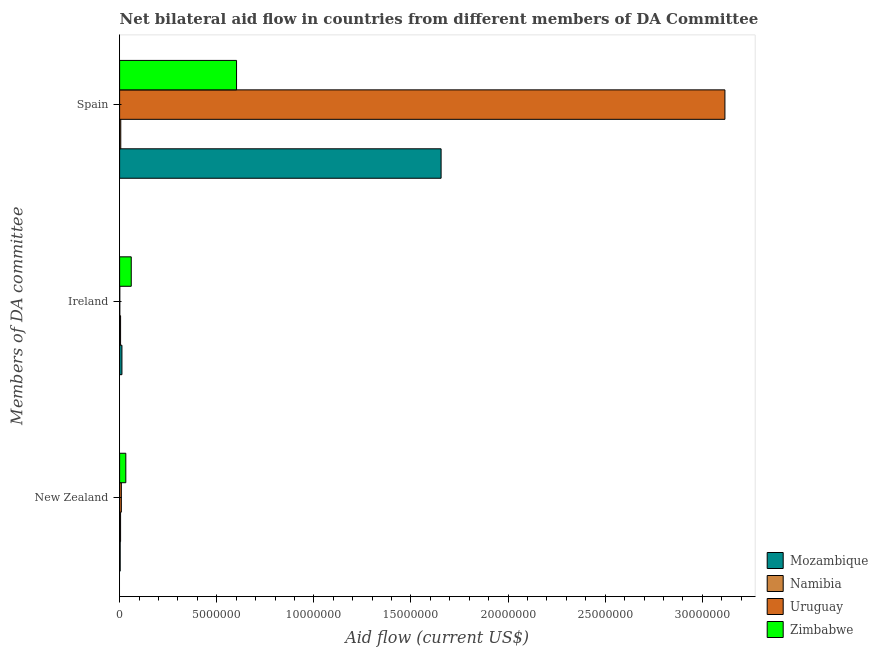Are the number of bars on each tick of the Y-axis equal?
Your answer should be compact. Yes. How many bars are there on the 1st tick from the top?
Provide a succinct answer. 4. What is the label of the 2nd group of bars from the top?
Ensure brevity in your answer.  Ireland. What is the amount of aid provided by ireland in Namibia?
Give a very brief answer. 5.00e+04. Across all countries, what is the maximum amount of aid provided by spain?
Your response must be concise. 3.12e+07. Across all countries, what is the minimum amount of aid provided by ireland?
Your answer should be very brief. 10000. In which country was the amount of aid provided by ireland maximum?
Ensure brevity in your answer.  Zimbabwe. In which country was the amount of aid provided by ireland minimum?
Give a very brief answer. Uruguay. What is the total amount of aid provided by ireland in the graph?
Provide a succinct answer. 7.80e+05. What is the difference between the amount of aid provided by new zealand in Namibia and that in Uruguay?
Your answer should be compact. -4.00e+04. What is the difference between the amount of aid provided by ireland in Namibia and the amount of aid provided by spain in Mozambique?
Provide a succinct answer. -1.65e+07. What is the average amount of aid provided by ireland per country?
Provide a short and direct response. 1.95e+05. What is the difference between the amount of aid provided by spain and amount of aid provided by new zealand in Zimbabwe?
Your answer should be very brief. 5.70e+06. In how many countries, is the amount of aid provided by ireland greater than 4000000 US$?
Keep it short and to the point. 0. What is the ratio of the amount of aid provided by spain in Namibia to that in Mozambique?
Give a very brief answer. 0. Is the amount of aid provided by new zealand in Zimbabwe less than that in Mozambique?
Your answer should be compact. No. What is the difference between the highest and the second highest amount of aid provided by spain?
Make the answer very short. 1.46e+07. What is the difference between the highest and the lowest amount of aid provided by new zealand?
Provide a short and direct response. 2.90e+05. In how many countries, is the amount of aid provided by spain greater than the average amount of aid provided by spain taken over all countries?
Provide a short and direct response. 2. What does the 3rd bar from the top in Ireland represents?
Your answer should be very brief. Namibia. What does the 2nd bar from the bottom in Ireland represents?
Offer a terse response. Namibia. Is it the case that in every country, the sum of the amount of aid provided by new zealand and amount of aid provided by ireland is greater than the amount of aid provided by spain?
Give a very brief answer. No. Where does the legend appear in the graph?
Provide a short and direct response. Bottom right. How many legend labels are there?
Make the answer very short. 4. What is the title of the graph?
Make the answer very short. Net bilateral aid flow in countries from different members of DA Committee. Does "Venezuela" appear as one of the legend labels in the graph?
Offer a terse response. No. What is the label or title of the X-axis?
Provide a short and direct response. Aid flow (current US$). What is the label or title of the Y-axis?
Offer a terse response. Members of DA committee. What is the Aid flow (current US$) of Uruguay in New Zealand?
Keep it short and to the point. 9.00e+04. What is the Aid flow (current US$) in Zimbabwe in New Zealand?
Provide a short and direct response. 3.20e+05. What is the Aid flow (current US$) of Namibia in Ireland?
Provide a short and direct response. 5.00e+04. What is the Aid flow (current US$) of Zimbabwe in Ireland?
Provide a succinct answer. 6.00e+05. What is the Aid flow (current US$) of Mozambique in Spain?
Make the answer very short. 1.66e+07. What is the Aid flow (current US$) in Uruguay in Spain?
Your response must be concise. 3.12e+07. What is the Aid flow (current US$) of Zimbabwe in Spain?
Provide a short and direct response. 6.02e+06. Across all Members of DA committee, what is the maximum Aid flow (current US$) of Mozambique?
Offer a very short reply. 1.66e+07. Across all Members of DA committee, what is the maximum Aid flow (current US$) of Namibia?
Make the answer very short. 6.00e+04. Across all Members of DA committee, what is the maximum Aid flow (current US$) of Uruguay?
Your answer should be compact. 3.12e+07. Across all Members of DA committee, what is the maximum Aid flow (current US$) in Zimbabwe?
Offer a very short reply. 6.02e+06. Across all Members of DA committee, what is the minimum Aid flow (current US$) in Mozambique?
Offer a terse response. 3.00e+04. Across all Members of DA committee, what is the minimum Aid flow (current US$) in Namibia?
Provide a short and direct response. 5.00e+04. Across all Members of DA committee, what is the minimum Aid flow (current US$) in Zimbabwe?
Provide a succinct answer. 3.20e+05. What is the total Aid flow (current US$) in Mozambique in the graph?
Provide a short and direct response. 1.67e+07. What is the total Aid flow (current US$) in Uruguay in the graph?
Offer a terse response. 3.13e+07. What is the total Aid flow (current US$) of Zimbabwe in the graph?
Make the answer very short. 6.94e+06. What is the difference between the Aid flow (current US$) of Mozambique in New Zealand and that in Ireland?
Give a very brief answer. -9.00e+04. What is the difference between the Aid flow (current US$) of Namibia in New Zealand and that in Ireland?
Provide a succinct answer. 0. What is the difference between the Aid flow (current US$) in Zimbabwe in New Zealand and that in Ireland?
Your response must be concise. -2.80e+05. What is the difference between the Aid flow (current US$) of Mozambique in New Zealand and that in Spain?
Keep it short and to the point. -1.65e+07. What is the difference between the Aid flow (current US$) of Uruguay in New Zealand and that in Spain?
Offer a very short reply. -3.11e+07. What is the difference between the Aid flow (current US$) of Zimbabwe in New Zealand and that in Spain?
Ensure brevity in your answer.  -5.70e+06. What is the difference between the Aid flow (current US$) in Mozambique in Ireland and that in Spain?
Your answer should be compact. -1.64e+07. What is the difference between the Aid flow (current US$) in Uruguay in Ireland and that in Spain?
Offer a very short reply. -3.12e+07. What is the difference between the Aid flow (current US$) of Zimbabwe in Ireland and that in Spain?
Your answer should be compact. -5.42e+06. What is the difference between the Aid flow (current US$) of Mozambique in New Zealand and the Aid flow (current US$) of Uruguay in Ireland?
Your answer should be compact. 2.00e+04. What is the difference between the Aid flow (current US$) in Mozambique in New Zealand and the Aid flow (current US$) in Zimbabwe in Ireland?
Your response must be concise. -5.70e+05. What is the difference between the Aid flow (current US$) in Namibia in New Zealand and the Aid flow (current US$) in Uruguay in Ireland?
Make the answer very short. 4.00e+04. What is the difference between the Aid flow (current US$) of Namibia in New Zealand and the Aid flow (current US$) of Zimbabwe in Ireland?
Offer a terse response. -5.50e+05. What is the difference between the Aid flow (current US$) of Uruguay in New Zealand and the Aid flow (current US$) of Zimbabwe in Ireland?
Your answer should be very brief. -5.10e+05. What is the difference between the Aid flow (current US$) in Mozambique in New Zealand and the Aid flow (current US$) in Namibia in Spain?
Provide a short and direct response. -3.00e+04. What is the difference between the Aid flow (current US$) in Mozambique in New Zealand and the Aid flow (current US$) in Uruguay in Spain?
Your answer should be very brief. -3.11e+07. What is the difference between the Aid flow (current US$) of Mozambique in New Zealand and the Aid flow (current US$) of Zimbabwe in Spain?
Your answer should be very brief. -5.99e+06. What is the difference between the Aid flow (current US$) of Namibia in New Zealand and the Aid flow (current US$) of Uruguay in Spain?
Your answer should be compact. -3.11e+07. What is the difference between the Aid flow (current US$) in Namibia in New Zealand and the Aid flow (current US$) in Zimbabwe in Spain?
Provide a short and direct response. -5.97e+06. What is the difference between the Aid flow (current US$) of Uruguay in New Zealand and the Aid flow (current US$) of Zimbabwe in Spain?
Offer a very short reply. -5.93e+06. What is the difference between the Aid flow (current US$) of Mozambique in Ireland and the Aid flow (current US$) of Uruguay in Spain?
Your answer should be very brief. -3.10e+07. What is the difference between the Aid flow (current US$) of Mozambique in Ireland and the Aid flow (current US$) of Zimbabwe in Spain?
Offer a very short reply. -5.90e+06. What is the difference between the Aid flow (current US$) in Namibia in Ireland and the Aid flow (current US$) in Uruguay in Spain?
Make the answer very short. -3.11e+07. What is the difference between the Aid flow (current US$) of Namibia in Ireland and the Aid flow (current US$) of Zimbabwe in Spain?
Give a very brief answer. -5.97e+06. What is the difference between the Aid flow (current US$) of Uruguay in Ireland and the Aid flow (current US$) of Zimbabwe in Spain?
Your answer should be compact. -6.01e+06. What is the average Aid flow (current US$) of Mozambique per Members of DA committee?
Provide a short and direct response. 5.57e+06. What is the average Aid flow (current US$) in Namibia per Members of DA committee?
Ensure brevity in your answer.  5.33e+04. What is the average Aid flow (current US$) in Uruguay per Members of DA committee?
Provide a short and direct response. 1.04e+07. What is the average Aid flow (current US$) in Zimbabwe per Members of DA committee?
Offer a terse response. 2.31e+06. What is the difference between the Aid flow (current US$) of Mozambique and Aid flow (current US$) of Zimbabwe in New Zealand?
Your answer should be very brief. -2.90e+05. What is the difference between the Aid flow (current US$) of Namibia and Aid flow (current US$) of Uruguay in New Zealand?
Your response must be concise. -4.00e+04. What is the difference between the Aid flow (current US$) in Namibia and Aid flow (current US$) in Zimbabwe in New Zealand?
Your answer should be very brief. -2.70e+05. What is the difference between the Aid flow (current US$) in Uruguay and Aid flow (current US$) in Zimbabwe in New Zealand?
Provide a short and direct response. -2.30e+05. What is the difference between the Aid flow (current US$) in Mozambique and Aid flow (current US$) in Namibia in Ireland?
Keep it short and to the point. 7.00e+04. What is the difference between the Aid flow (current US$) in Mozambique and Aid flow (current US$) in Zimbabwe in Ireland?
Your answer should be compact. -4.80e+05. What is the difference between the Aid flow (current US$) in Namibia and Aid flow (current US$) in Uruguay in Ireland?
Ensure brevity in your answer.  4.00e+04. What is the difference between the Aid flow (current US$) of Namibia and Aid flow (current US$) of Zimbabwe in Ireland?
Your answer should be compact. -5.50e+05. What is the difference between the Aid flow (current US$) of Uruguay and Aid flow (current US$) of Zimbabwe in Ireland?
Provide a succinct answer. -5.90e+05. What is the difference between the Aid flow (current US$) in Mozambique and Aid flow (current US$) in Namibia in Spain?
Ensure brevity in your answer.  1.65e+07. What is the difference between the Aid flow (current US$) in Mozambique and Aid flow (current US$) in Uruguay in Spain?
Your answer should be very brief. -1.46e+07. What is the difference between the Aid flow (current US$) of Mozambique and Aid flow (current US$) of Zimbabwe in Spain?
Your answer should be very brief. 1.05e+07. What is the difference between the Aid flow (current US$) in Namibia and Aid flow (current US$) in Uruguay in Spain?
Keep it short and to the point. -3.11e+07. What is the difference between the Aid flow (current US$) of Namibia and Aid flow (current US$) of Zimbabwe in Spain?
Make the answer very short. -5.96e+06. What is the difference between the Aid flow (current US$) of Uruguay and Aid flow (current US$) of Zimbabwe in Spain?
Your response must be concise. 2.51e+07. What is the ratio of the Aid flow (current US$) of Namibia in New Zealand to that in Ireland?
Give a very brief answer. 1. What is the ratio of the Aid flow (current US$) of Uruguay in New Zealand to that in Ireland?
Your answer should be very brief. 9. What is the ratio of the Aid flow (current US$) of Zimbabwe in New Zealand to that in Ireland?
Offer a very short reply. 0.53. What is the ratio of the Aid flow (current US$) of Mozambique in New Zealand to that in Spain?
Offer a terse response. 0. What is the ratio of the Aid flow (current US$) in Namibia in New Zealand to that in Spain?
Your response must be concise. 0.83. What is the ratio of the Aid flow (current US$) in Uruguay in New Zealand to that in Spain?
Give a very brief answer. 0. What is the ratio of the Aid flow (current US$) of Zimbabwe in New Zealand to that in Spain?
Provide a succinct answer. 0.05. What is the ratio of the Aid flow (current US$) in Mozambique in Ireland to that in Spain?
Ensure brevity in your answer.  0.01. What is the ratio of the Aid flow (current US$) in Zimbabwe in Ireland to that in Spain?
Your answer should be very brief. 0.1. What is the difference between the highest and the second highest Aid flow (current US$) of Mozambique?
Provide a succinct answer. 1.64e+07. What is the difference between the highest and the second highest Aid flow (current US$) in Namibia?
Your answer should be very brief. 10000. What is the difference between the highest and the second highest Aid flow (current US$) in Uruguay?
Offer a terse response. 3.11e+07. What is the difference between the highest and the second highest Aid flow (current US$) of Zimbabwe?
Keep it short and to the point. 5.42e+06. What is the difference between the highest and the lowest Aid flow (current US$) of Mozambique?
Make the answer very short. 1.65e+07. What is the difference between the highest and the lowest Aid flow (current US$) of Namibia?
Your answer should be very brief. 10000. What is the difference between the highest and the lowest Aid flow (current US$) of Uruguay?
Make the answer very short. 3.12e+07. What is the difference between the highest and the lowest Aid flow (current US$) in Zimbabwe?
Your response must be concise. 5.70e+06. 